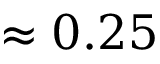Convert formula to latex. <formula><loc_0><loc_0><loc_500><loc_500>\approx 0 . 2 5</formula> 